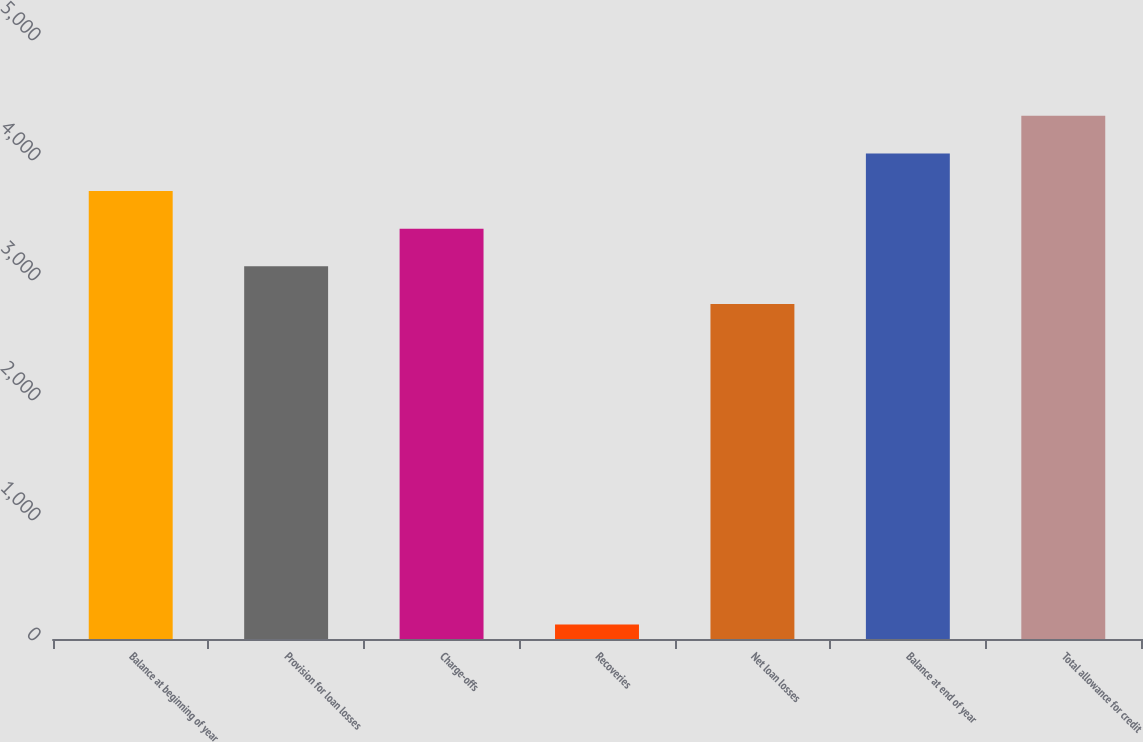Convert chart to OTSL. <chart><loc_0><loc_0><loc_500><loc_500><bar_chart><fcel>Balance at beginning of year<fcel>Provision for loan losses<fcel>Charge-offs<fcel>Recoveries<fcel>Net loan losses<fcel>Balance at end of year<fcel>Total allowance for credit<nl><fcel>3732.8<fcel>3105.6<fcel>3419.2<fcel>120<fcel>2792<fcel>4046.4<fcel>4360<nl></chart> 